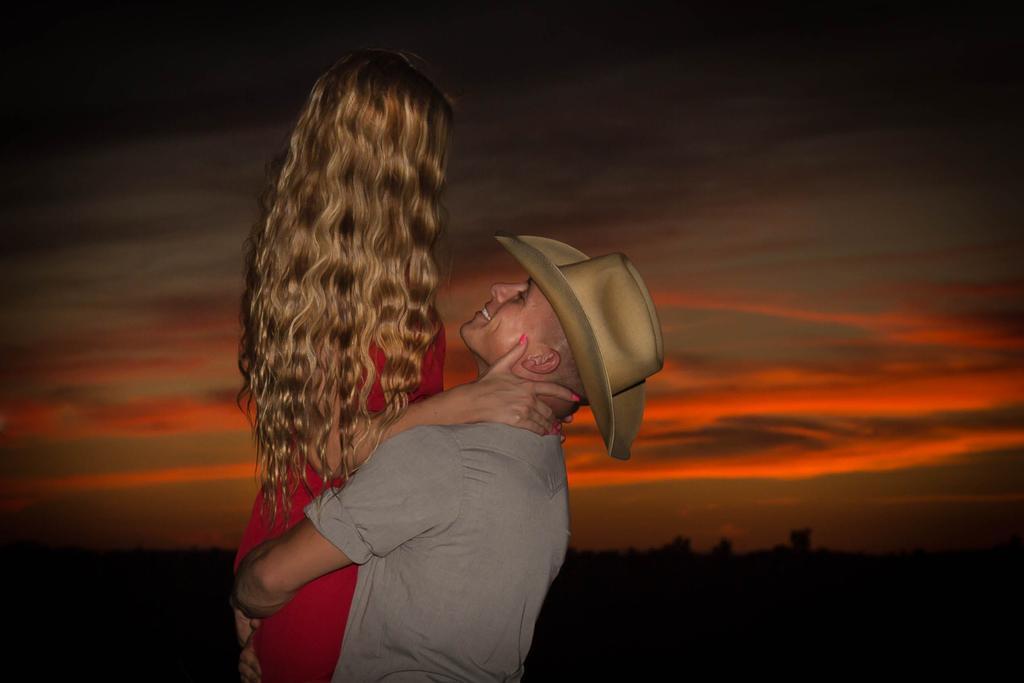In one or two sentences, can you explain what this image depicts? In this image, there are a few people. We can also see the background and the sky with clouds. 